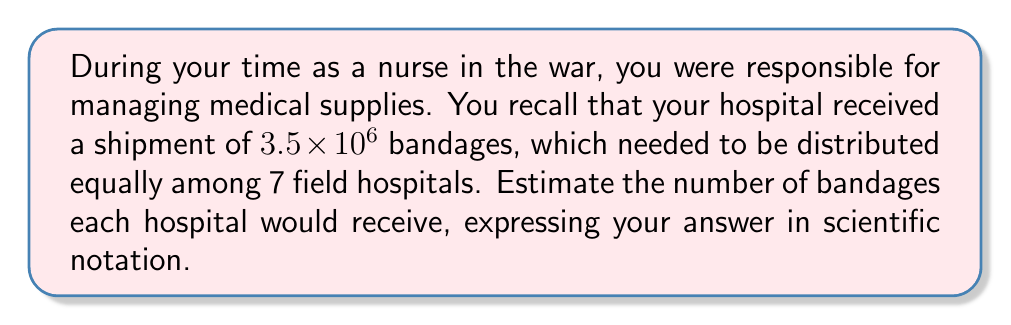Give your solution to this math problem. Let's approach this step-by-step:

1) We start with 3.5 × 10⁶ bandages in total.

2) We need to divide this amount by 7 (the number of field hospitals).

3) In scientific notation, we can write this as:

   $\frac{3.5 \times 10^6}{7}$

4) First, let's divide 3.5 by 7:

   $\frac{3.5}{7} = 0.5$

5) Now our expression looks like this:

   $0.5 \times 10^6$

6) However, in scientific notation, we need the first number to be between 1 and 10. To achieve this, we move the decimal point one place to the right and decrease the exponent by 1:

   $5 \times 10^5$

Thus, each hospital would receive approximately 5 × 10⁵ bandages.
Answer: $5 \times 10^5$ 